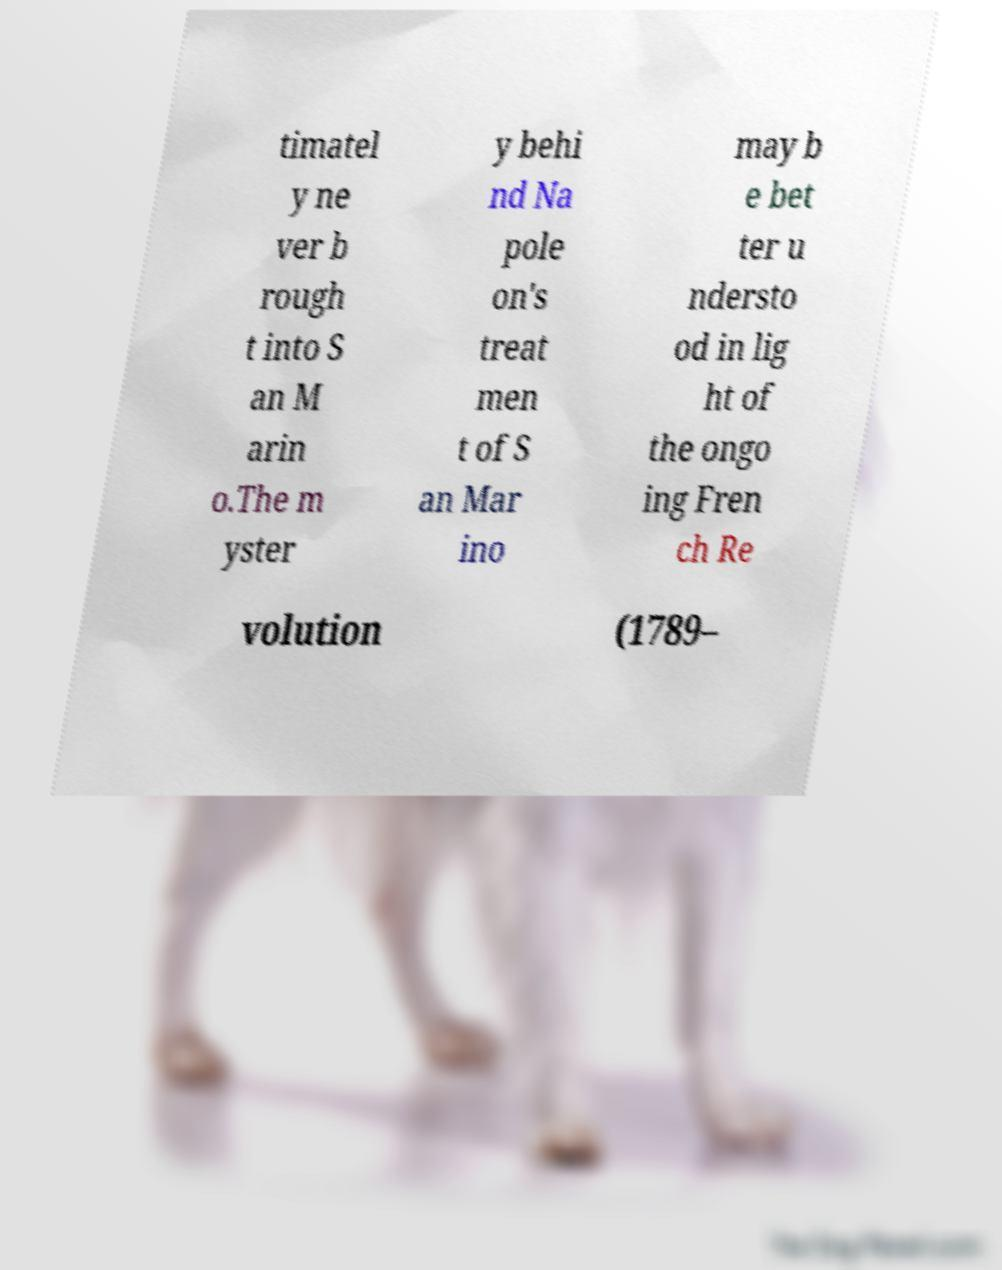For documentation purposes, I need the text within this image transcribed. Could you provide that? timatel y ne ver b rough t into S an M arin o.The m yster y behi nd Na pole on's treat men t of S an Mar ino may b e bet ter u ndersto od in lig ht of the ongo ing Fren ch Re volution (1789– 